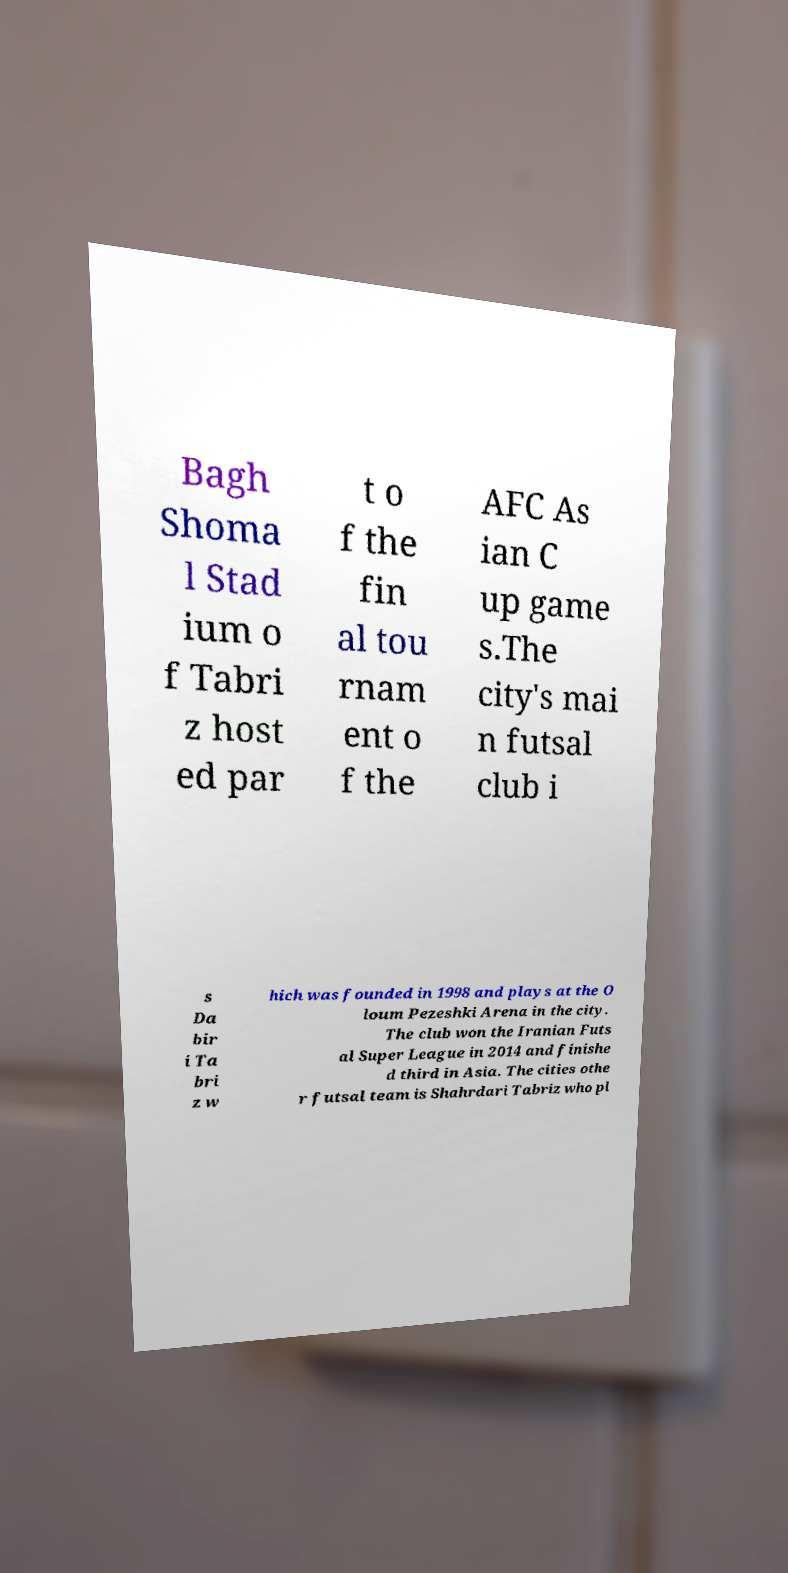Please read and relay the text visible in this image. What does it say? Bagh Shoma l Stad ium o f Tabri z host ed par t o f the fin al tou rnam ent o f the AFC As ian C up game s.The city's mai n futsal club i s Da bir i Ta bri z w hich was founded in 1998 and plays at the O loum Pezeshki Arena in the city. The club won the Iranian Futs al Super League in 2014 and finishe d third in Asia. The cities othe r futsal team is Shahrdari Tabriz who pl 